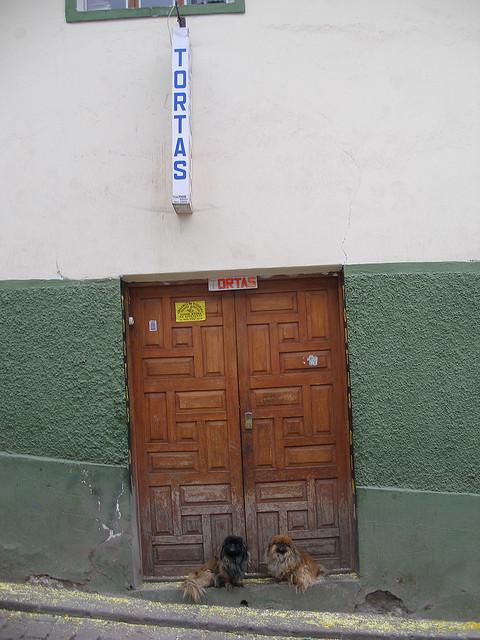What does the white sign say?
Answer briefly. Tortas. Is the door straight?
Keep it brief. No. What is sitting in front of the door?
Give a very brief answer. Dogs. 